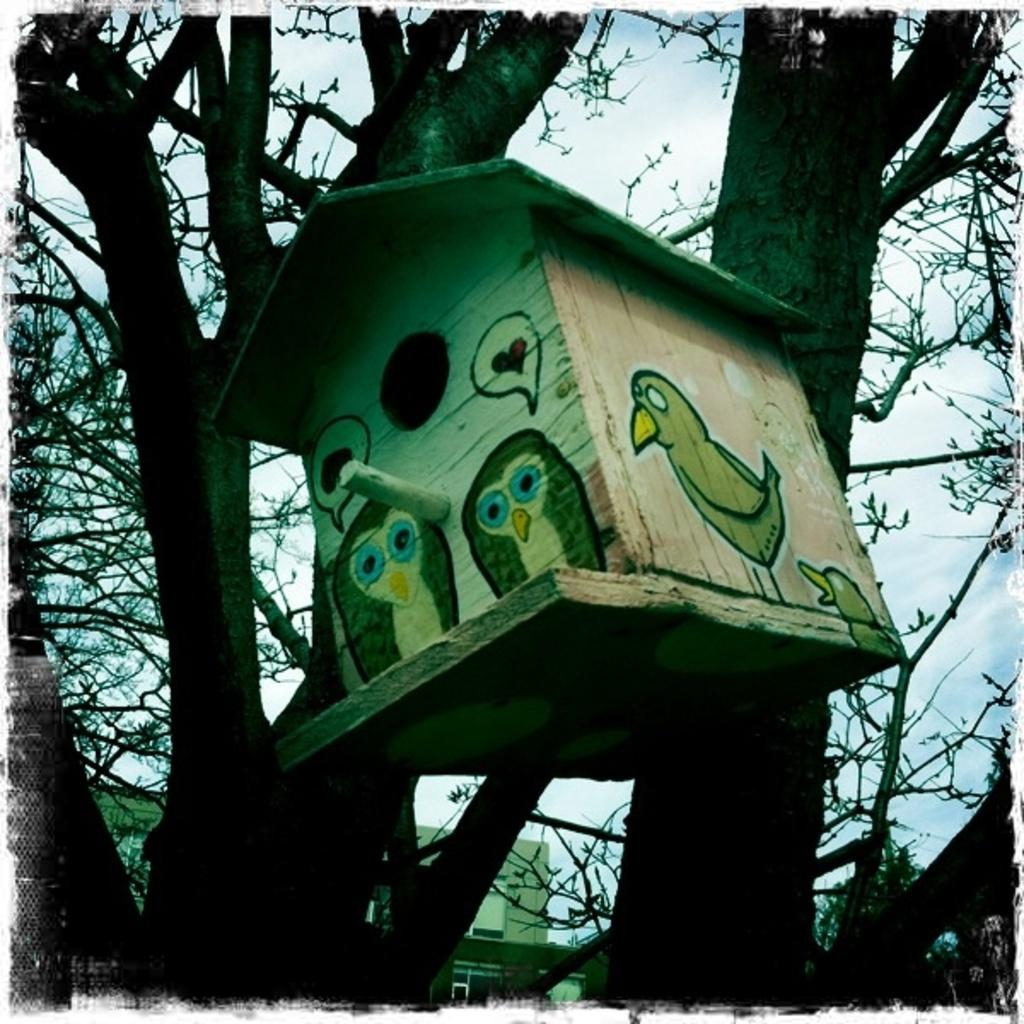What is located in the foreground of the image? There is a bird house in the foreground of the image. How is the bird house positioned in the image? The bird house is hanging on a tree. What can be seen in the background of the image? There is a building and the sky visible in the background of the image. What type of crime is being committed in the image? There is no indication of any crime being committed in the image; it features a bird house hanging on a tree and a background with a building and the sky. 